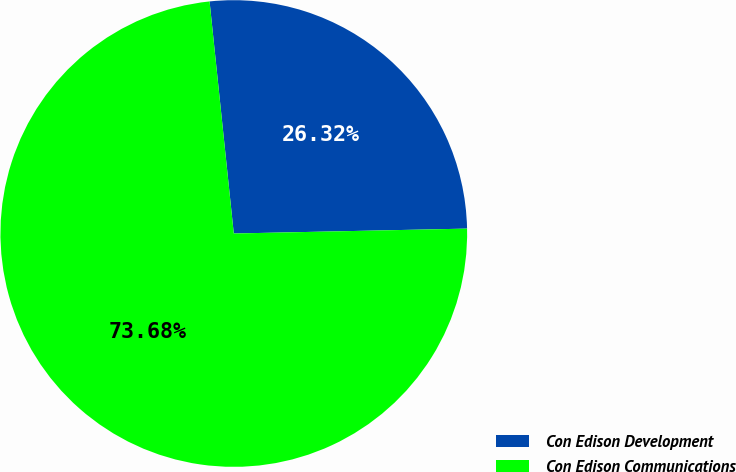<chart> <loc_0><loc_0><loc_500><loc_500><pie_chart><fcel>Con Edison Development<fcel>Con Edison Communications<nl><fcel>26.32%<fcel>73.68%<nl></chart> 